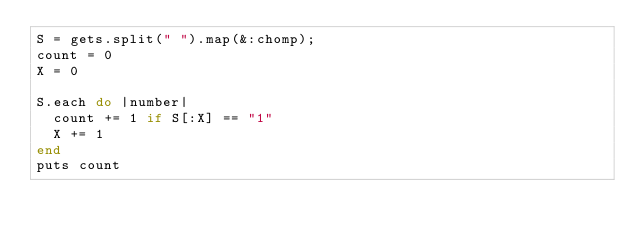<code> <loc_0><loc_0><loc_500><loc_500><_Ruby_>S = gets.split(" ").map(&:chomp);
count = 0
X = 0
 
S.each do |number|
  count += 1 if S[:X] == "1"
  X += 1
end
puts count</code> 